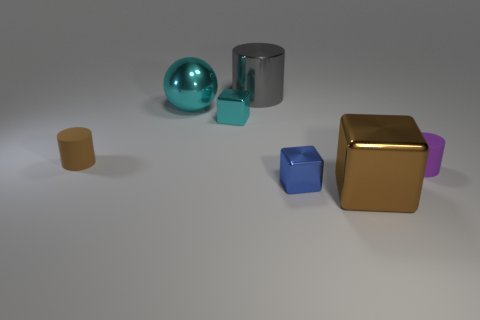Add 1 cyan shiny blocks. How many objects exist? 8 Subtract all balls. How many objects are left? 6 Subtract all big blue metal cylinders. Subtract all tiny blue objects. How many objects are left? 6 Add 6 cyan objects. How many cyan objects are left? 8 Add 2 blue things. How many blue things exist? 3 Subtract 1 purple cylinders. How many objects are left? 6 